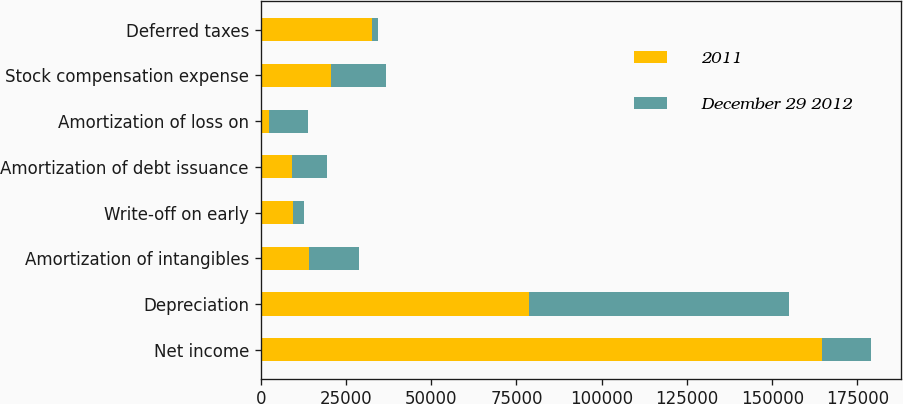Convert chart. <chart><loc_0><loc_0><loc_500><loc_500><stacked_bar_chart><ecel><fcel>Net income<fcel>Depreciation<fcel>Amortization of intangibles<fcel>Write-off on early<fcel>Amortization of debt issuance<fcel>Amortization of loss on<fcel>Stock compensation expense<fcel>Deferred taxes<nl><fcel>2011<fcel>164681<fcel>78784<fcel>14252<fcel>9559<fcel>9168<fcel>2560<fcel>20496<fcel>32583<nl><fcel>December 29 2012<fcel>14252<fcel>76174<fcel>14551<fcel>3297<fcel>10367<fcel>11292<fcel>16173<fcel>1948<nl></chart> 